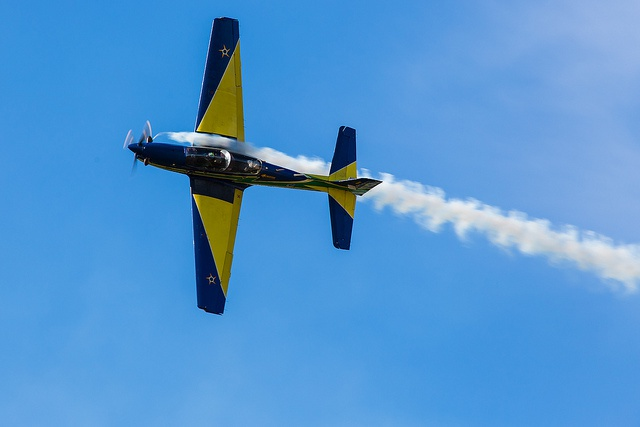Describe the objects in this image and their specific colors. I can see a airplane in gray, black, navy, and olive tones in this image. 